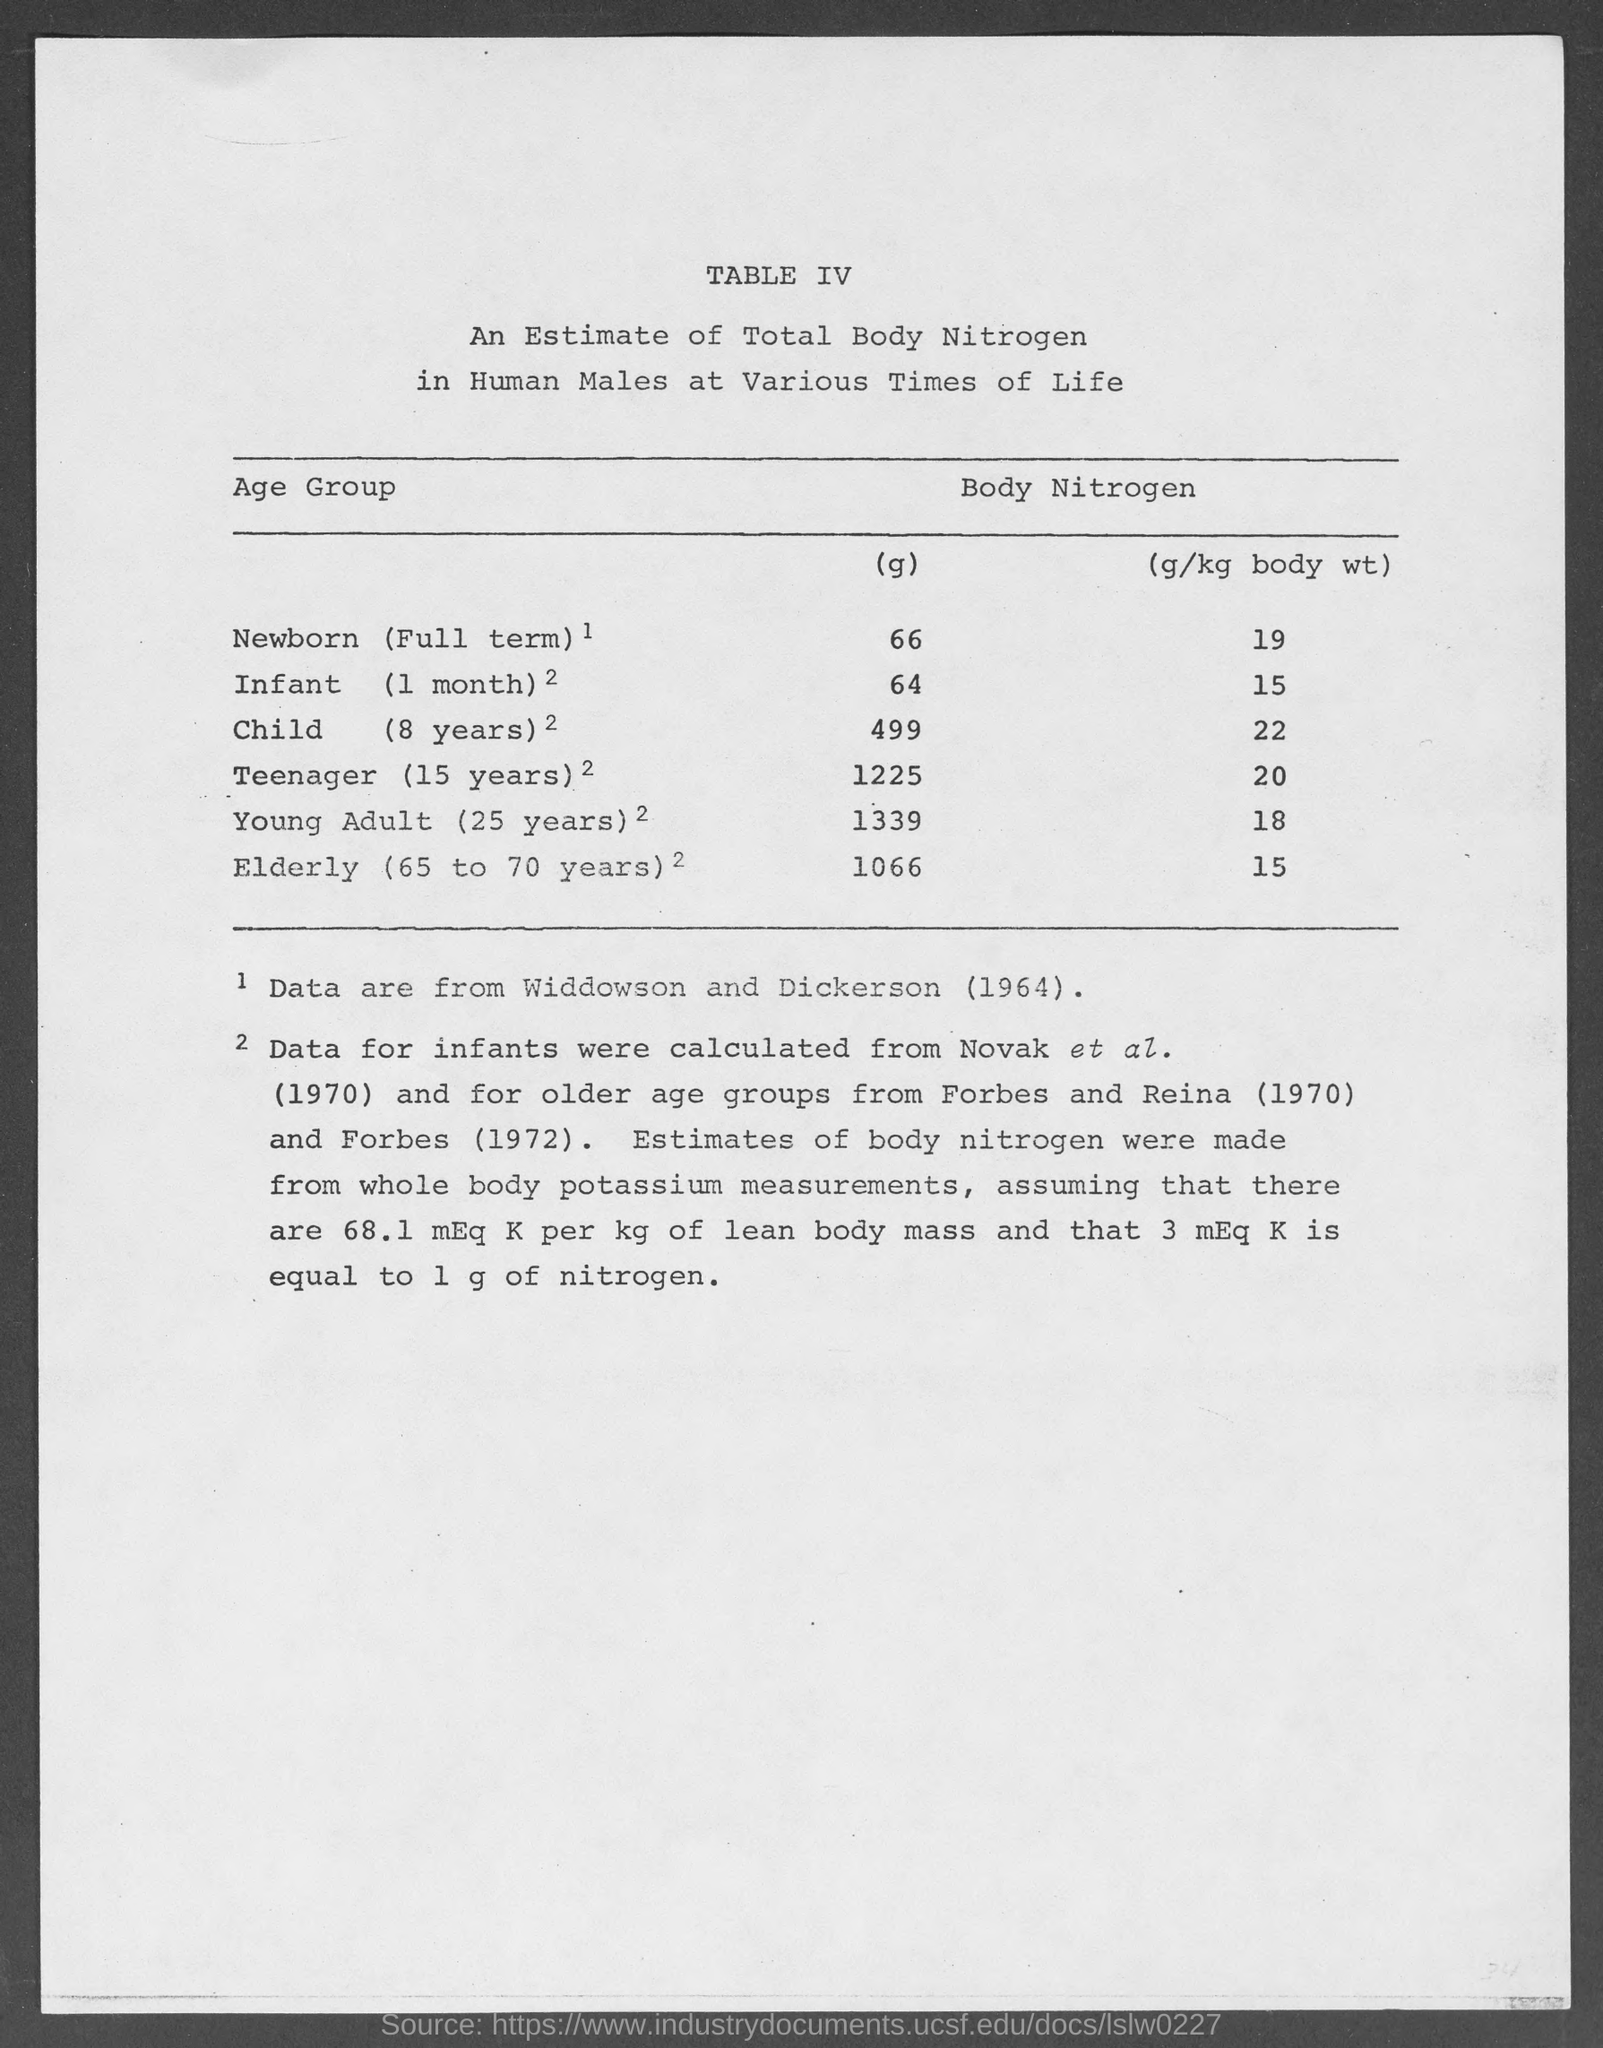List a handful of essential elements in this visual. The amount of body nitrogen in elderly individuals (65 to 70 years old) is approximately 1066 grams. The amount of body nitrogen in a young adult (25 years) is 1339 grams. The amount of body nitrogen in a newborn, born at full term, is approximately 19 g per kilogram of body weight. The amount of body nitrogen in an 8-year-old child is approximately 22 grams per kilogram of body weight. The amount of body nitrogen in a teenager (15 years old) is 1225 grams. 